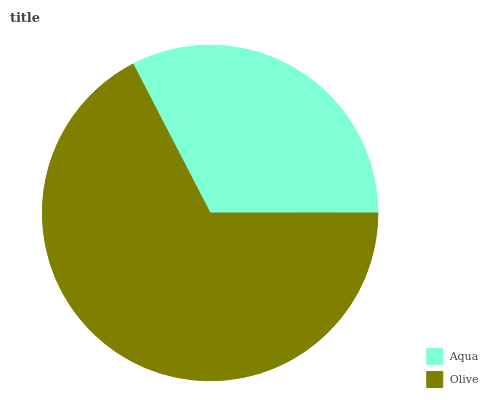Is Aqua the minimum?
Answer yes or no. Yes. Is Olive the maximum?
Answer yes or no. Yes. Is Olive the minimum?
Answer yes or no. No. Is Olive greater than Aqua?
Answer yes or no. Yes. Is Aqua less than Olive?
Answer yes or no. Yes. Is Aqua greater than Olive?
Answer yes or no. No. Is Olive less than Aqua?
Answer yes or no. No. Is Olive the high median?
Answer yes or no. Yes. Is Aqua the low median?
Answer yes or no. Yes. Is Aqua the high median?
Answer yes or no. No. Is Olive the low median?
Answer yes or no. No. 